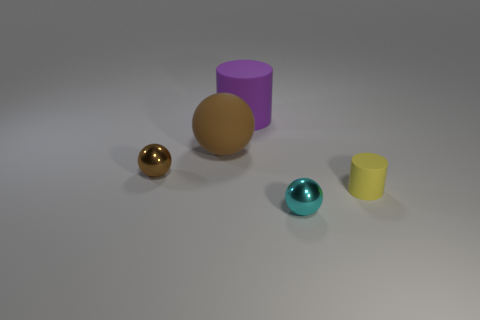What shape is the large brown matte object?
Keep it short and to the point. Sphere. What is the shape of the matte thing on the right side of the shiny object that is right of the purple matte object?
Your answer should be very brief. Cylinder. There is a tiny object that is the same color as the large rubber sphere; what material is it?
Your response must be concise. Metal. What color is the small thing that is made of the same material as the big brown object?
Your response must be concise. Yellow. Are there any other things that are the same size as the brown rubber thing?
Ensure brevity in your answer.  Yes. There is a matte cylinder on the left side of the yellow cylinder; is its color the same as the tiny sphere on the right side of the brown rubber ball?
Offer a terse response. No. Are there more tiny metallic spheres that are on the right side of the large purple cylinder than tiny metal things on the right side of the cyan sphere?
Offer a terse response. Yes. What color is the big thing that is the same shape as the small yellow rubber thing?
Keep it short and to the point. Purple. Is there anything else that has the same shape as the big purple object?
Give a very brief answer. Yes. There is a small brown object; does it have the same shape as the small object that is to the right of the tiny cyan metal ball?
Your response must be concise. No. 